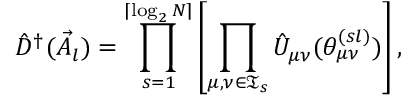<formula> <loc_0><loc_0><loc_500><loc_500>\hat { D } ^ { \dagger } ( \vec { A } _ { l } ) = \prod _ { s = 1 } ^ { \lceil \log _ { 2 } N \rceil } \left [ \prod _ { \mu , \nu \in \mathfrak { T } _ { s } } \hat { U } _ { \mu \nu } ( \theta _ { \mu \nu } ^ { ( s l ) } ) \right ] ,</formula> 